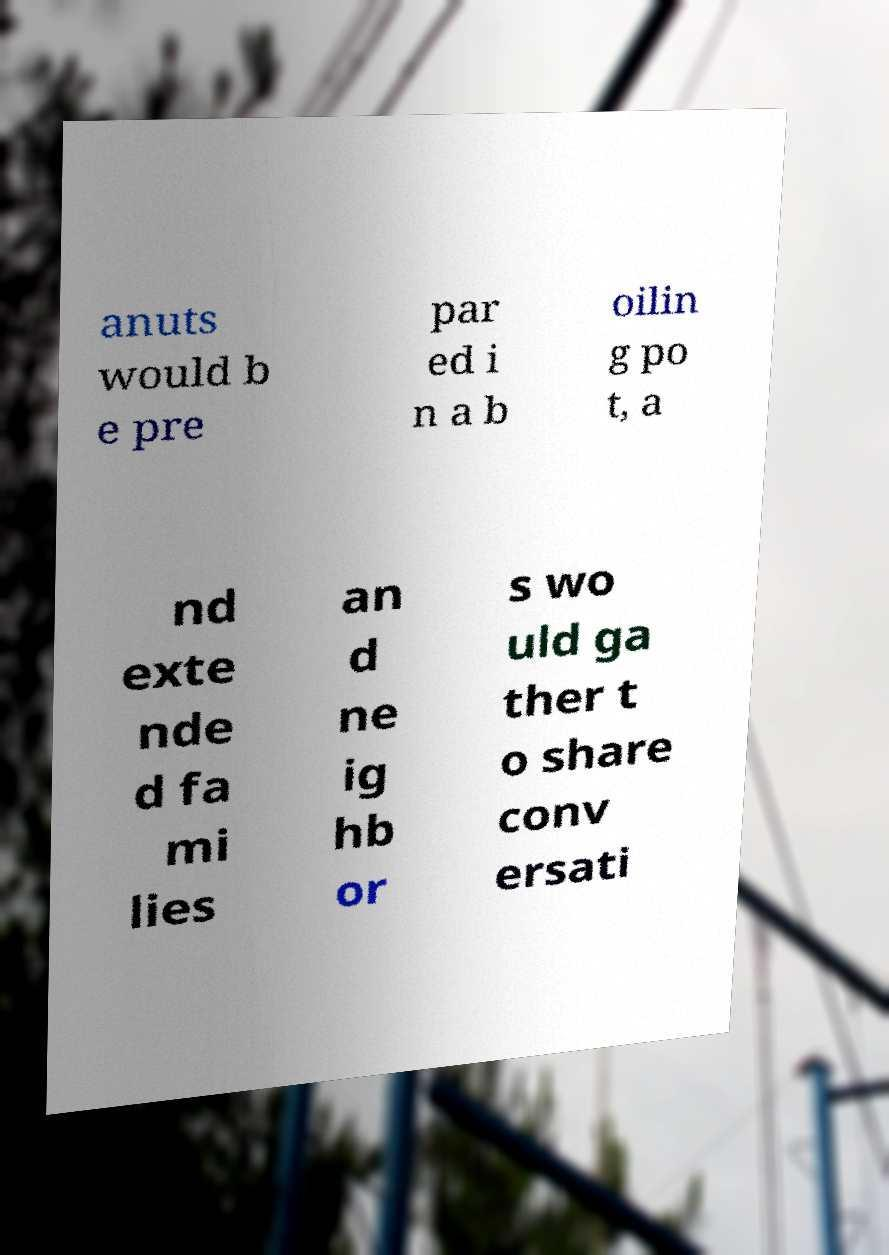Could you extract and type out the text from this image? anuts would b e pre par ed i n a b oilin g po t, a nd exte nde d fa mi lies an d ne ig hb or s wo uld ga ther t o share conv ersati 